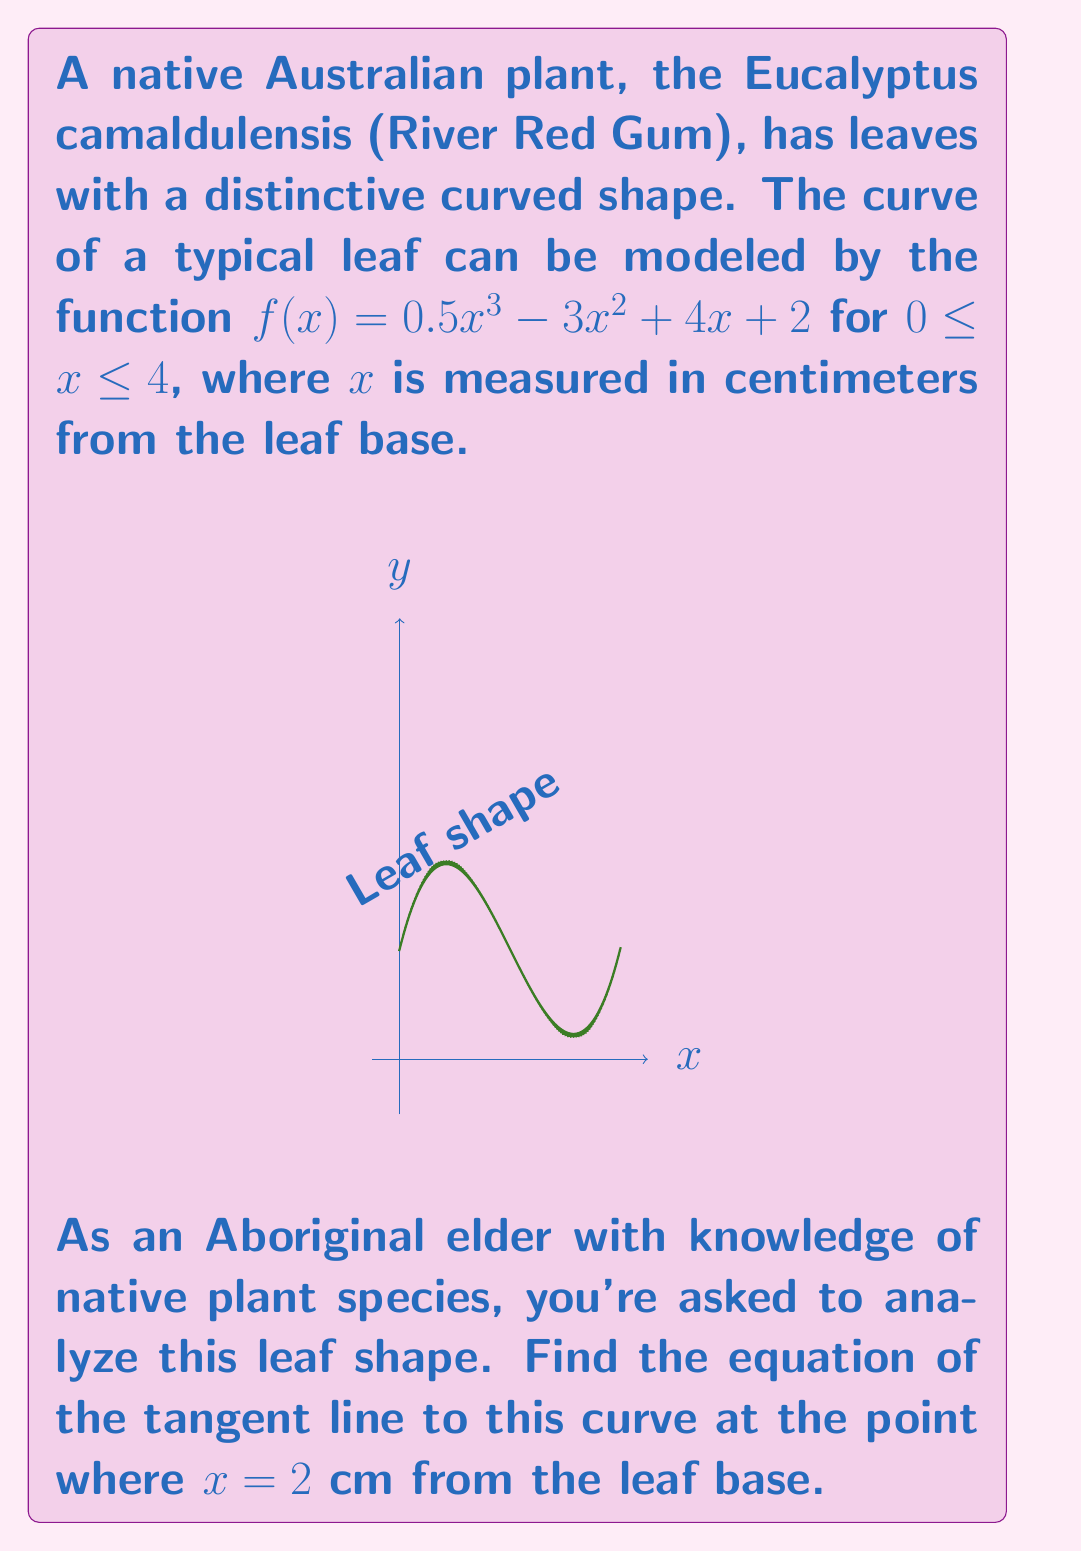Can you solve this math problem? To find the equation of the tangent line, we need to follow these steps:

1) The general equation of a tangent line is $y = mx + b$, where $m$ is the slope of the line and $b$ is the y-intercept.

2) To find the slope, we need to calculate the derivative of $f(x)$ and evaluate it at $x = 2$.

3) The derivative of $f(x)$ is:
   $$f'(x) = \frac{d}{dx}(0.5x^3 - 3x^2 + 4x + 2) = 1.5x^2 - 6x + 4$$

4) Evaluating $f'(x)$ at $x = 2$:
   $$f'(2) = 1.5(2)^2 - 6(2) + 4 = 6 - 12 + 4 = -2$$

5) So, the slope of the tangent line at $x = 2$ is $-2$.

6) Now we need to find a point on the curve to determine $b$. We can find this by evaluating $f(2)$:
   $$f(2) = 0.5(2)^3 - 3(2)^2 + 4(2) + 2 = 4 - 12 + 8 + 2 = 2$$

7) So, the point on the curve is $(2, 2)$.

8) Using the point-slope form of a line, $y - y_1 = m(x - x_1)$, we get:
   $$y - 2 = -2(x - 2)$$

9) Simplifying:
   $$y = -2x + 4 + 2 = -2x + 6$$

Therefore, the equation of the tangent line is $y = -2x + 6$.
Answer: $y = -2x + 6$ 